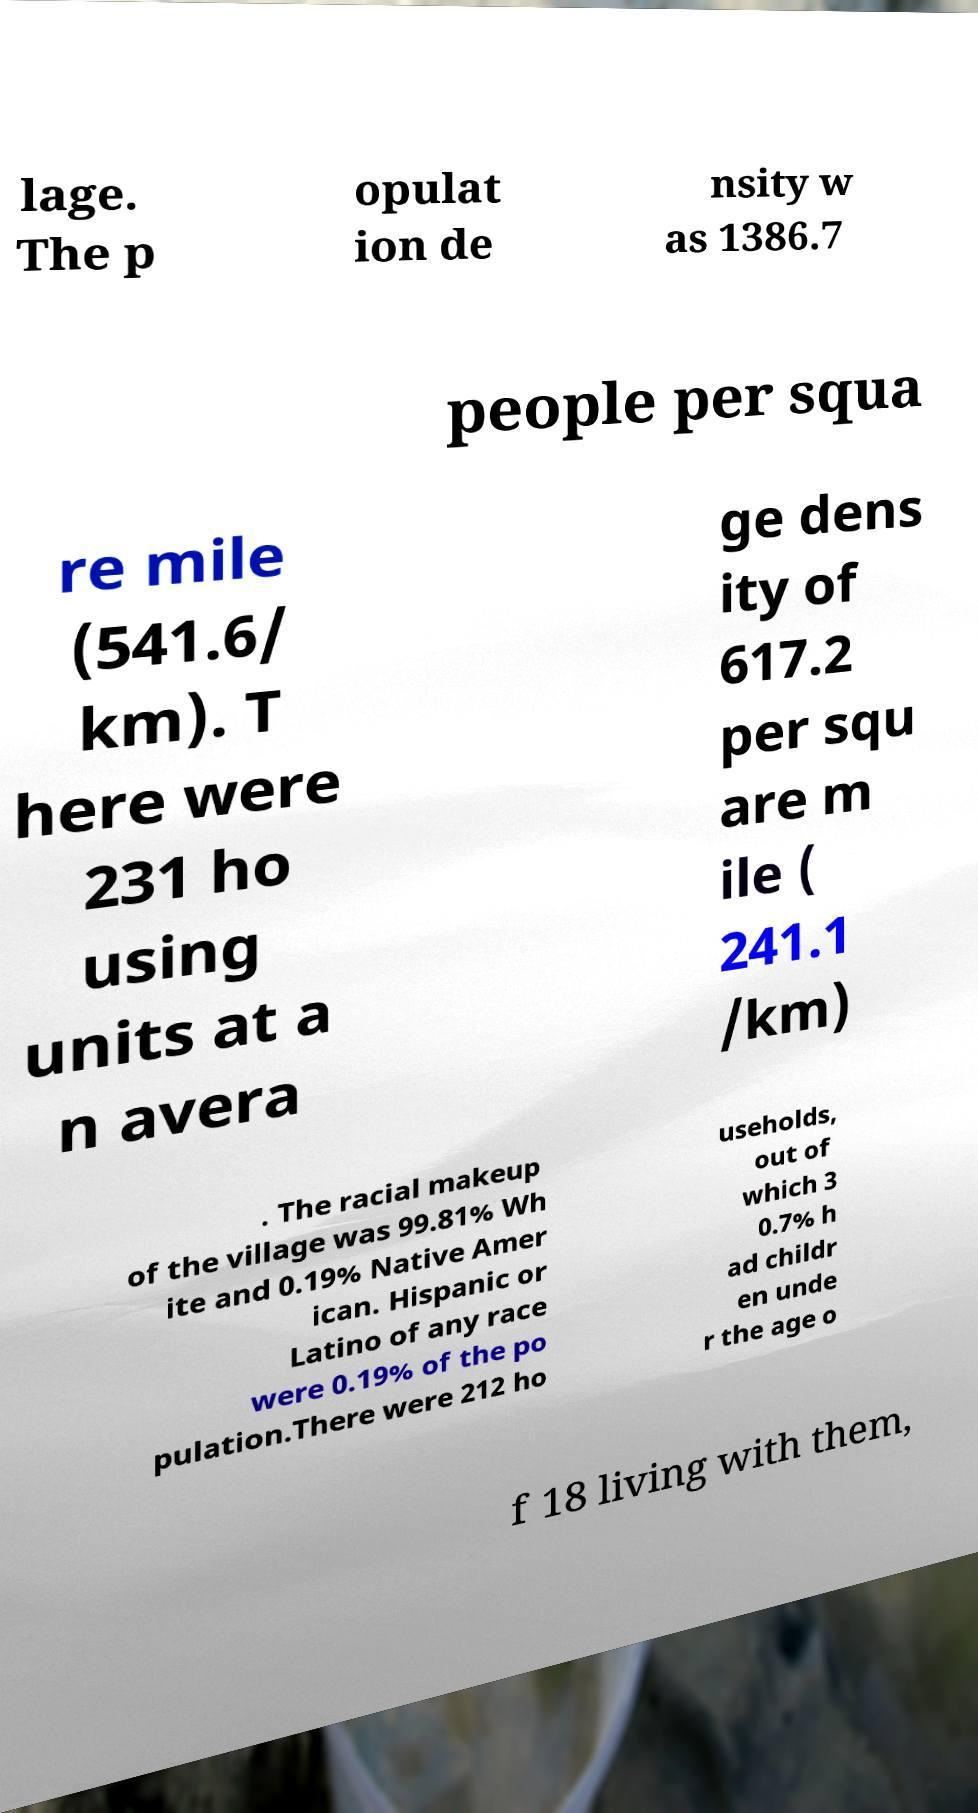Please read and relay the text visible in this image. What does it say? lage. The p opulat ion de nsity w as 1386.7 people per squa re mile (541.6/ km). T here were 231 ho using units at a n avera ge dens ity of 617.2 per squ are m ile ( 241.1 /km) . The racial makeup of the village was 99.81% Wh ite and 0.19% Native Amer ican. Hispanic or Latino of any race were 0.19% of the po pulation.There were 212 ho useholds, out of which 3 0.7% h ad childr en unde r the age o f 18 living with them, 